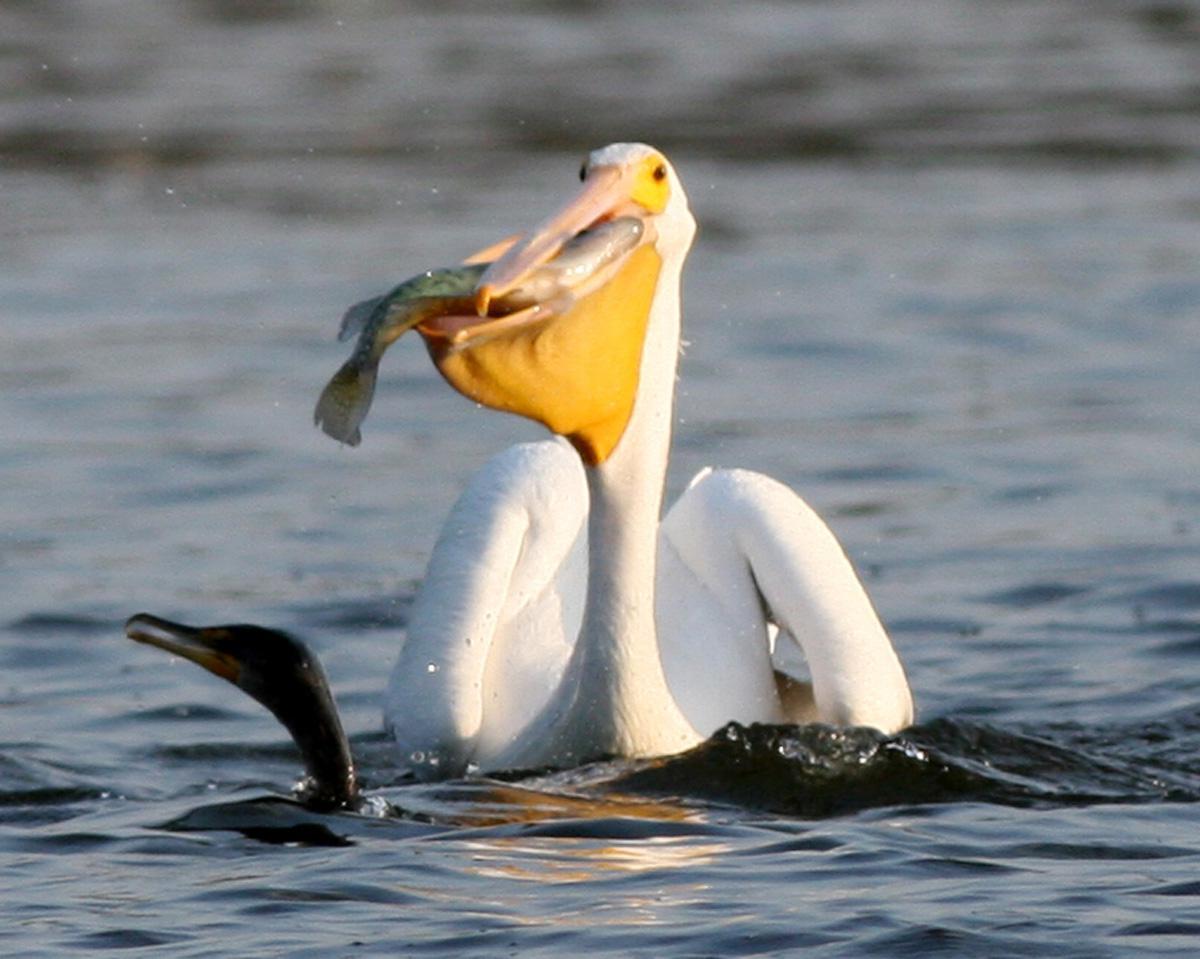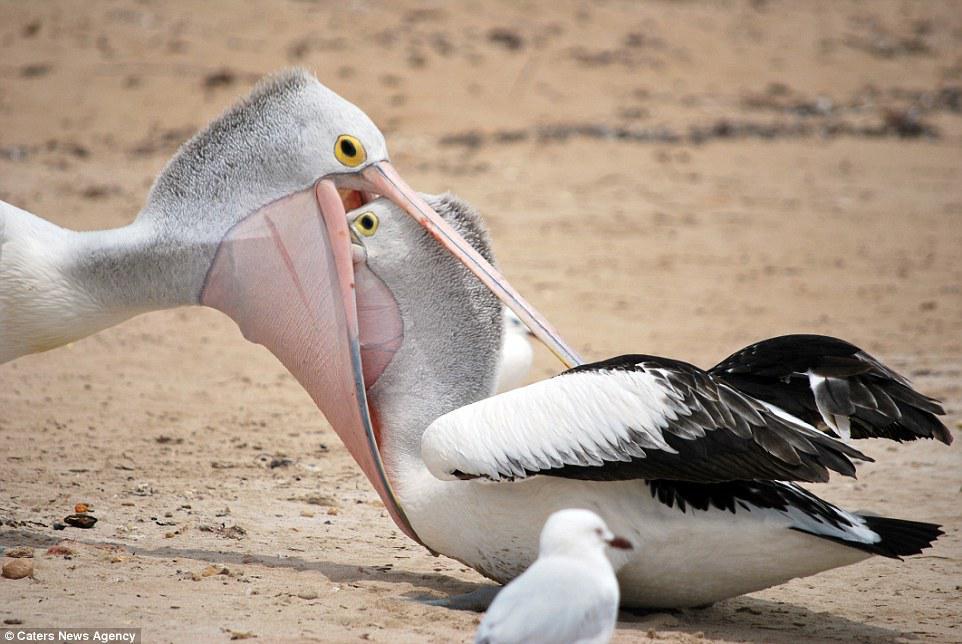The first image is the image on the left, the second image is the image on the right. Evaluate the accuracy of this statement regarding the images: "A fish is in a bird's mouth.". Is it true? Answer yes or no. Yes. 